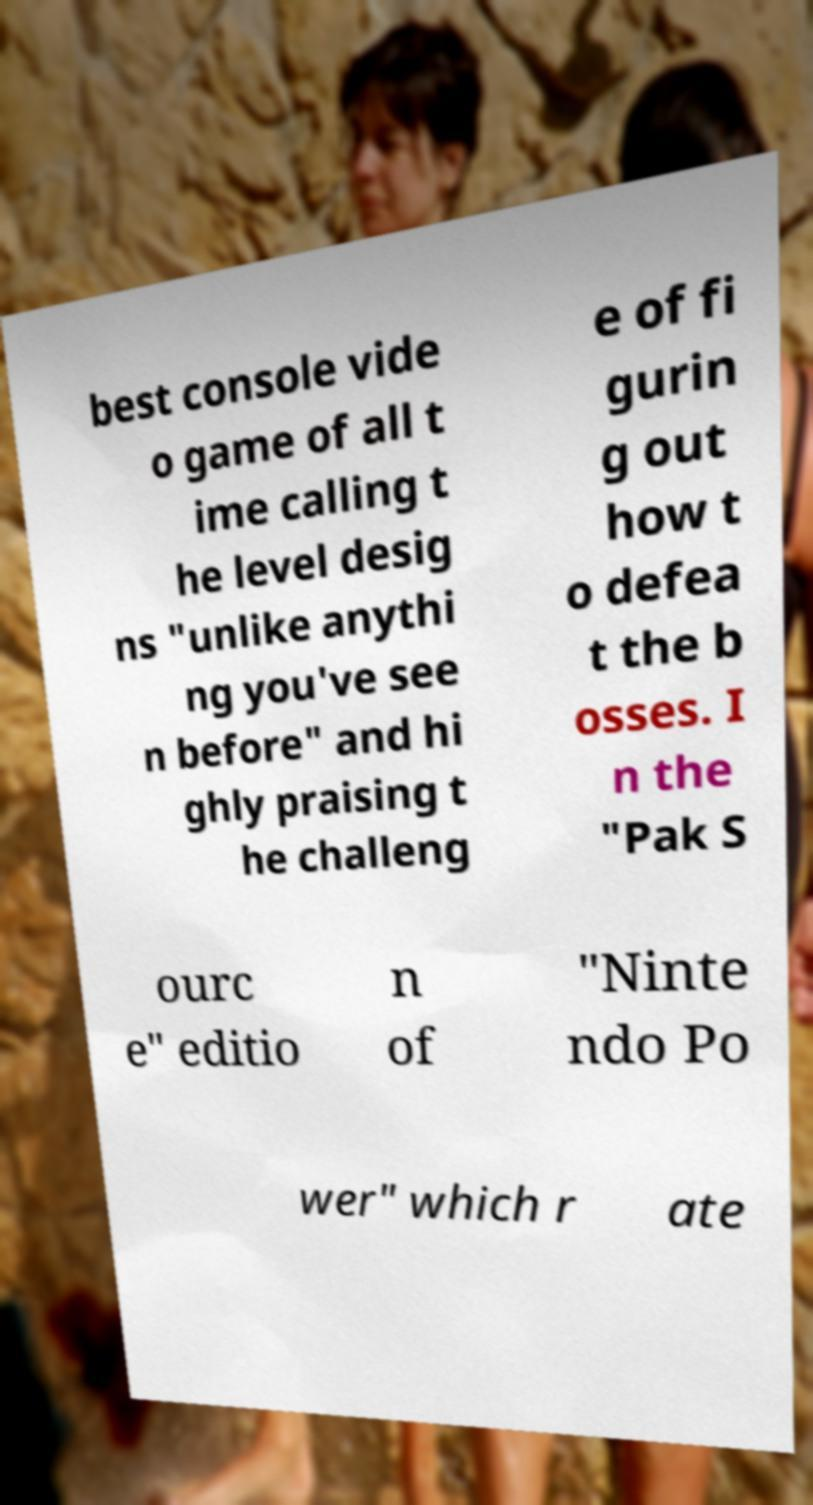Please identify and transcribe the text found in this image. best console vide o game of all t ime calling t he level desig ns "unlike anythi ng you've see n before" and hi ghly praising t he challeng e of fi gurin g out how t o defea t the b osses. I n the "Pak S ourc e" editio n of "Ninte ndo Po wer" which r ate 